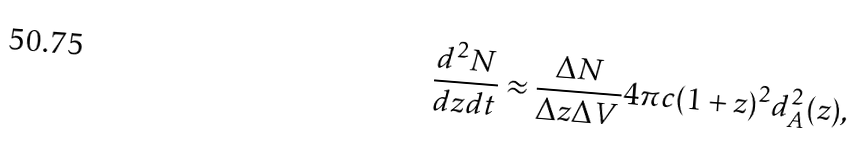Convert formula to latex. <formula><loc_0><loc_0><loc_500><loc_500>\frac { d ^ { 2 } N } { d z d t } \approx \frac { \Delta N } { \Delta z \Delta V } 4 \pi c ( 1 + z ) ^ { 2 } d _ { A } ^ { 2 } ( z ) ,</formula> 